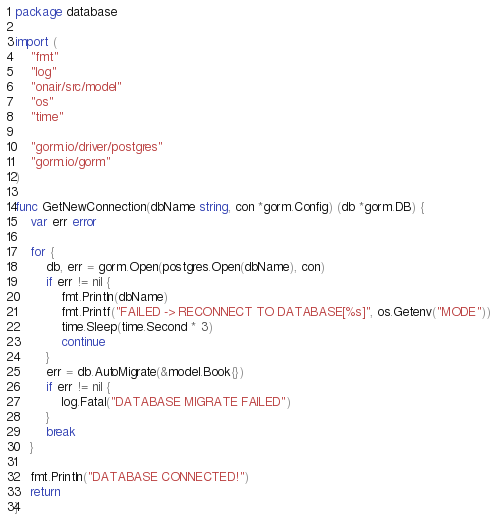Convert code to text. <code><loc_0><loc_0><loc_500><loc_500><_Go_>package database

import (
	"fmt"
	"log"
	"onair/src/model"
	"os"
	"time"

	"gorm.io/driver/postgres"
	"gorm.io/gorm"
)

func GetNewConnection(dbName string, con *gorm.Config) (db *gorm.DB) {
	var err error

	for {
		db, err = gorm.Open(postgres.Open(dbName), con)
		if err != nil {
			fmt.Println(dbName)
			fmt.Printf("FAILED -> RECONNECT TO DATABASE[%s]", os.Getenv("MODE"))
			time.Sleep(time.Second * 3)
			continue
		}
		err = db.AutoMigrate(&model.Book{})
		if err != nil {
			log.Fatal("DATABASE MIGRATE FAILED")
		}
		break
	}

	fmt.Println("DATABASE CONNECTED!")
	return
}
</code> 